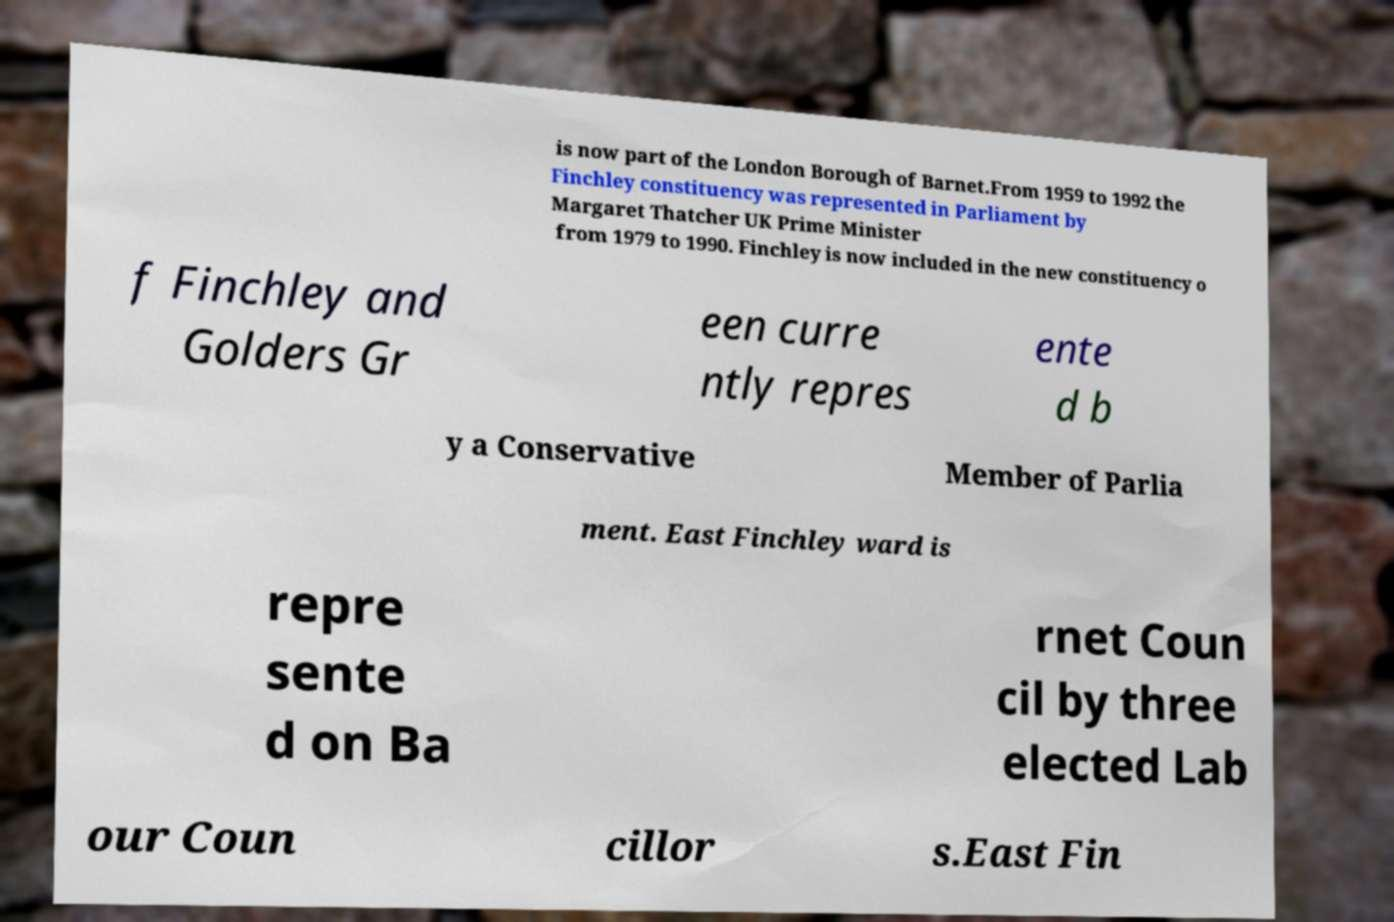What messages or text are displayed in this image? I need them in a readable, typed format. is now part of the London Borough of Barnet.From 1959 to 1992 the Finchley constituency was represented in Parliament by Margaret Thatcher UK Prime Minister from 1979 to 1990. Finchley is now included in the new constituency o f Finchley and Golders Gr een curre ntly repres ente d b y a Conservative Member of Parlia ment. East Finchley ward is repre sente d on Ba rnet Coun cil by three elected Lab our Coun cillor s.East Fin 